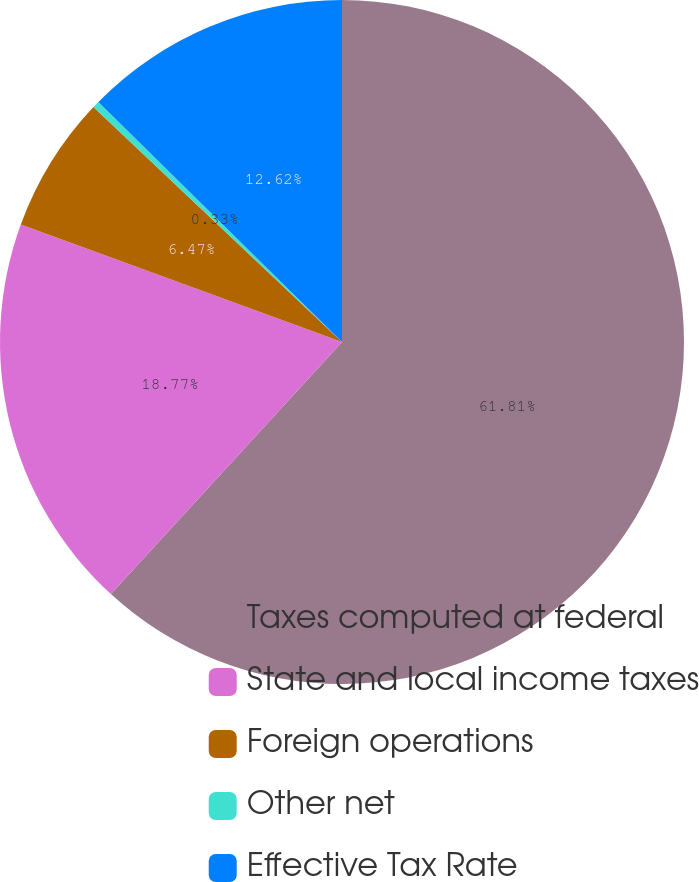<chart> <loc_0><loc_0><loc_500><loc_500><pie_chart><fcel>Taxes computed at federal<fcel>State and local income taxes<fcel>Foreign operations<fcel>Other net<fcel>Effective Tax Rate<nl><fcel>61.81%<fcel>18.77%<fcel>6.47%<fcel>0.33%<fcel>12.62%<nl></chart> 